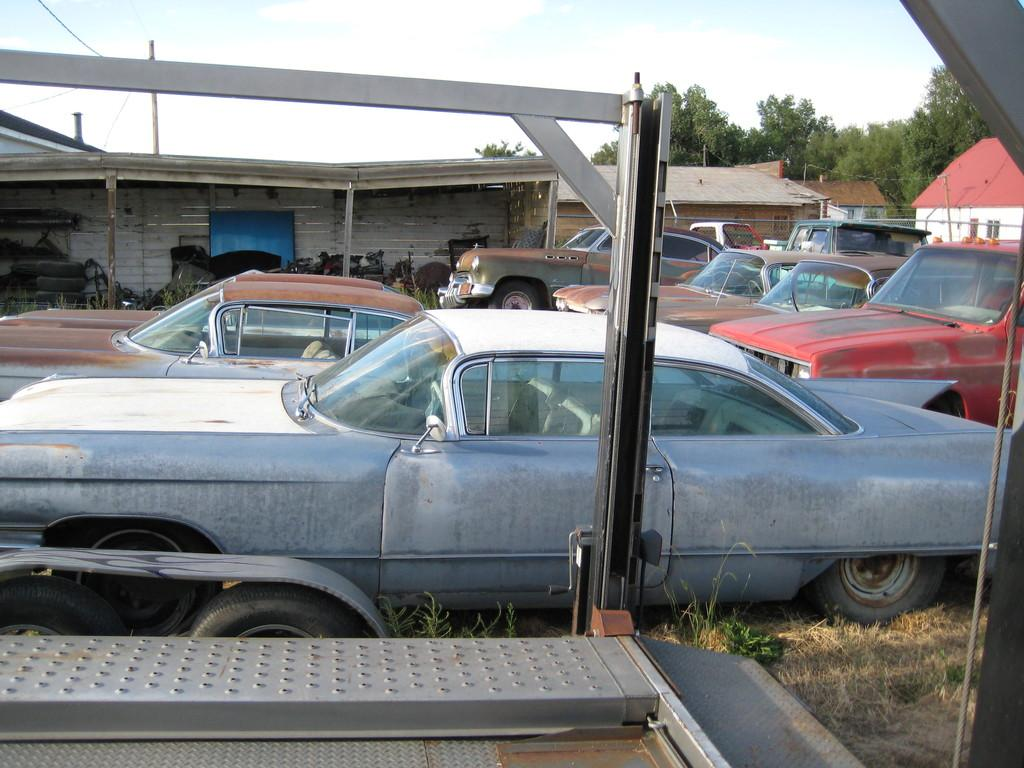What is the unusual location for the parked vehicles in the image? The vehicles are parked on the grass in the image. What can be seen in the distance behind the parked vehicles? There is a shed, objects, houses, trees, and the sky visible in the background of the image. How does the bear pull the end of the rope in the image? There is no bear or rope present in the image. 